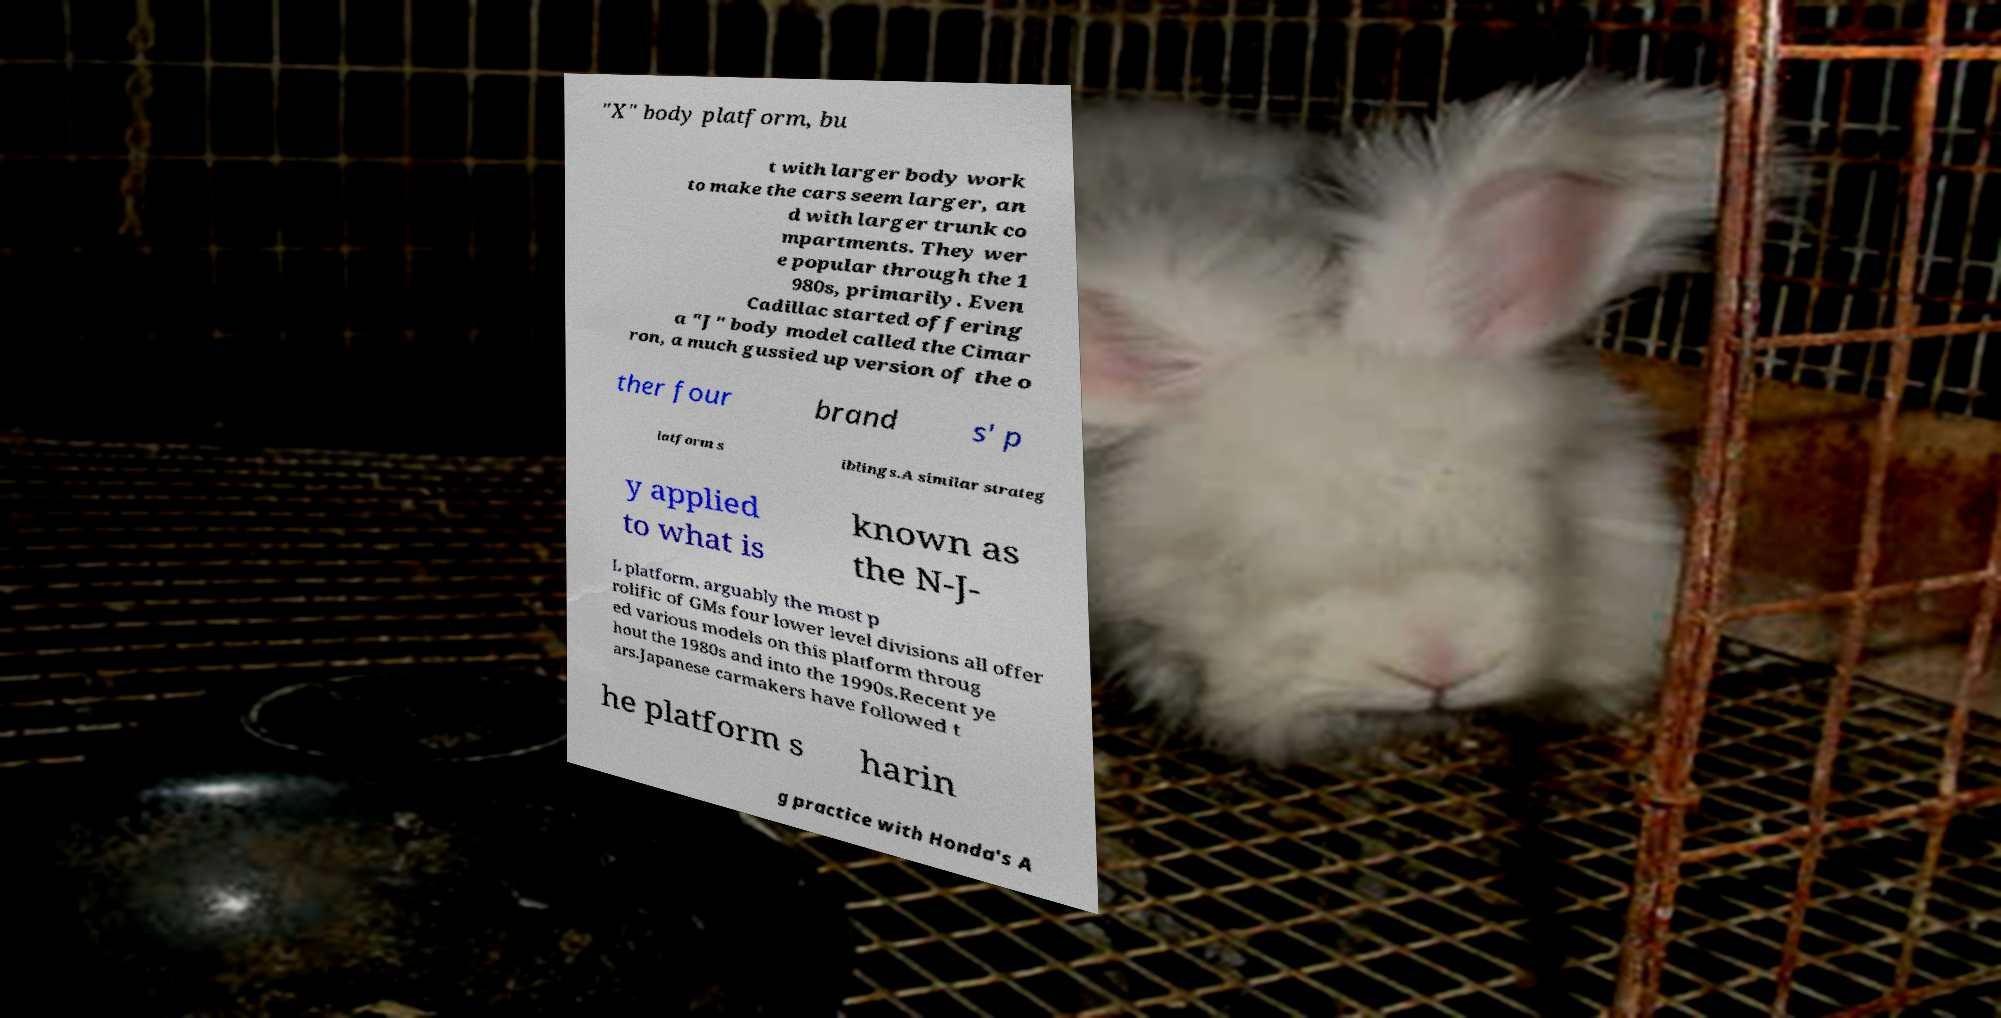What messages or text are displayed in this image? I need them in a readable, typed format. "X" body platform, bu t with larger body work to make the cars seem larger, an d with larger trunk co mpartments. They wer e popular through the 1 980s, primarily. Even Cadillac started offering a "J" body model called the Cimar ron, a much gussied up version of the o ther four brand s' p latform s iblings.A similar strateg y applied to what is known as the N-J- L platform, arguably the most p rolific of GMs four lower level divisions all offer ed various models on this platform throug hout the 1980s and into the 1990s.Recent ye ars.Japanese carmakers have followed t he platform s harin g practice with Honda's A 